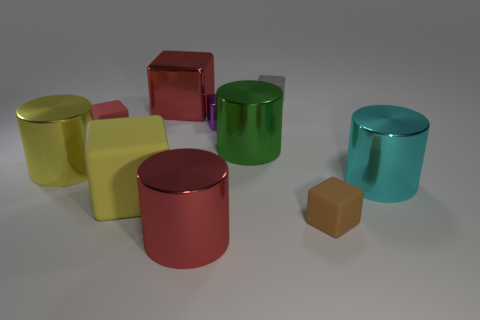There is a small thing that is the same color as the large shiny cube; what shape is it?
Your answer should be very brief. Cube. What number of small matte objects are left of the red shiny thing behind the large thing that is on the right side of the small brown matte block?
Your answer should be compact. 1. How big is the cylinder to the left of the small rubber block to the left of the small purple block?
Ensure brevity in your answer.  Large. There is a yellow cylinder that is made of the same material as the tiny purple cube; what size is it?
Keep it short and to the point. Large. There is a matte object that is behind the big yellow matte object and right of the small red object; what shape is it?
Offer a terse response. Cube. Are there an equal number of small rubber cubes that are in front of the small brown cube and gray objects?
Your answer should be very brief. No. How many things are green cylinders or red shiny objects behind the yellow metal cylinder?
Keep it short and to the point. 2. Are there any other matte things that have the same shape as the cyan object?
Give a very brief answer. No. Is the number of cylinders in front of the big yellow cylinder the same as the number of large green things that are to the left of the purple metal thing?
Give a very brief answer. No. Are there any other things that have the same size as the green cylinder?
Offer a terse response. Yes. 